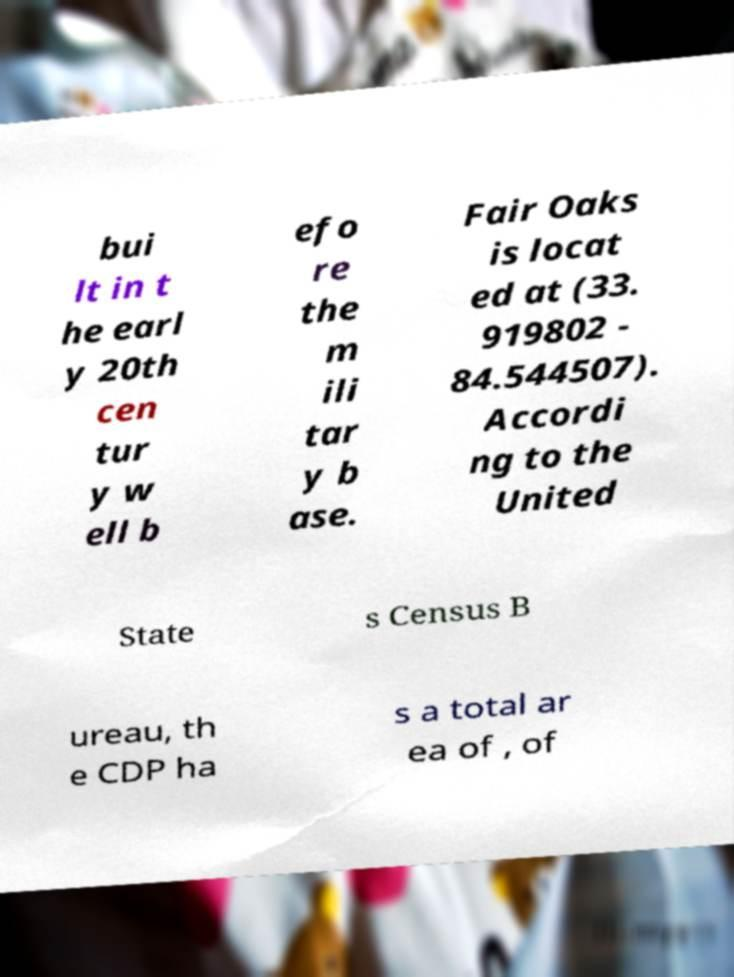For documentation purposes, I need the text within this image transcribed. Could you provide that? bui lt in t he earl y 20th cen tur y w ell b efo re the m ili tar y b ase. Fair Oaks is locat ed at (33. 919802 - 84.544507). Accordi ng to the United State s Census B ureau, th e CDP ha s a total ar ea of , of 